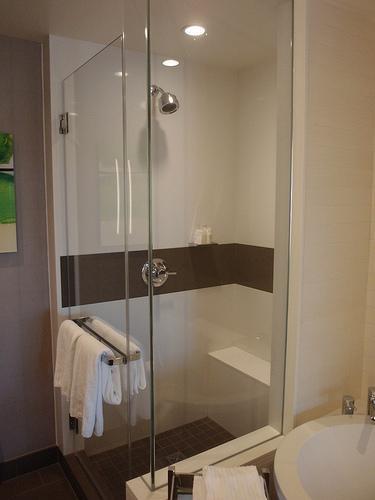How many lights are visible?
Give a very brief answer. 2. 